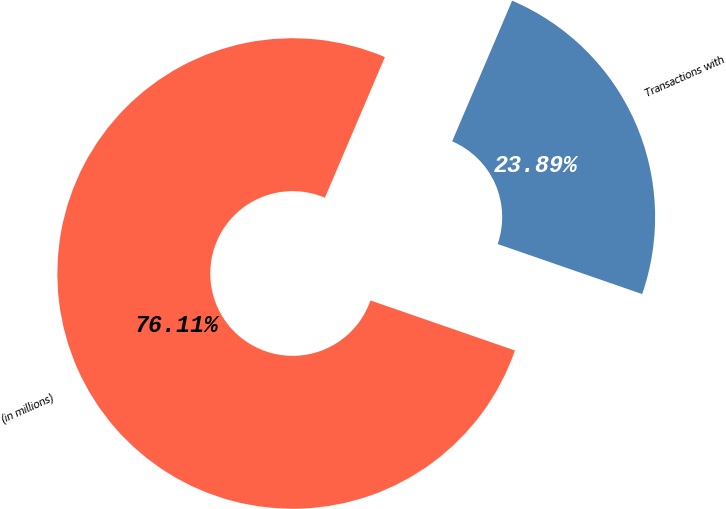Convert chart. <chart><loc_0><loc_0><loc_500><loc_500><pie_chart><fcel>(in millions)<fcel>Transactions with<nl><fcel>76.11%<fcel>23.89%<nl></chart> 